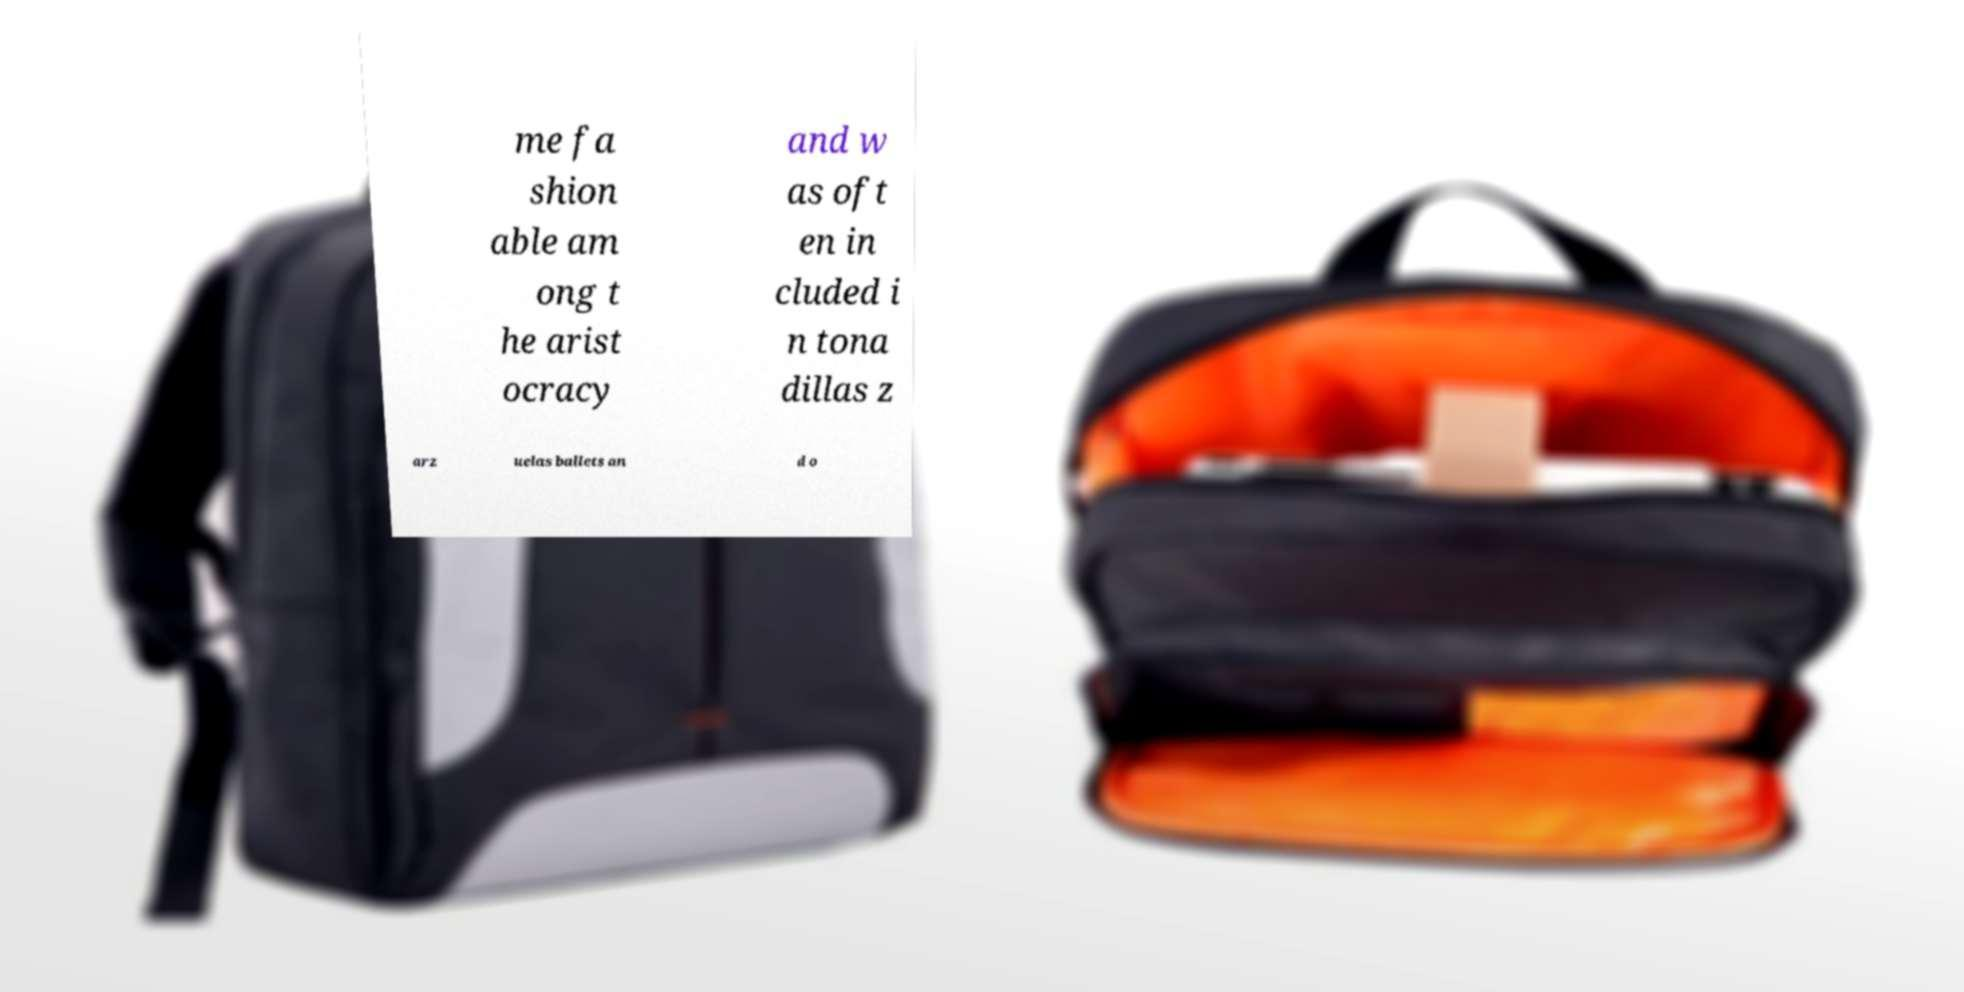Could you assist in decoding the text presented in this image and type it out clearly? me fa shion able am ong t he arist ocracy and w as oft en in cluded i n tona dillas z arz uelas ballets an d o 